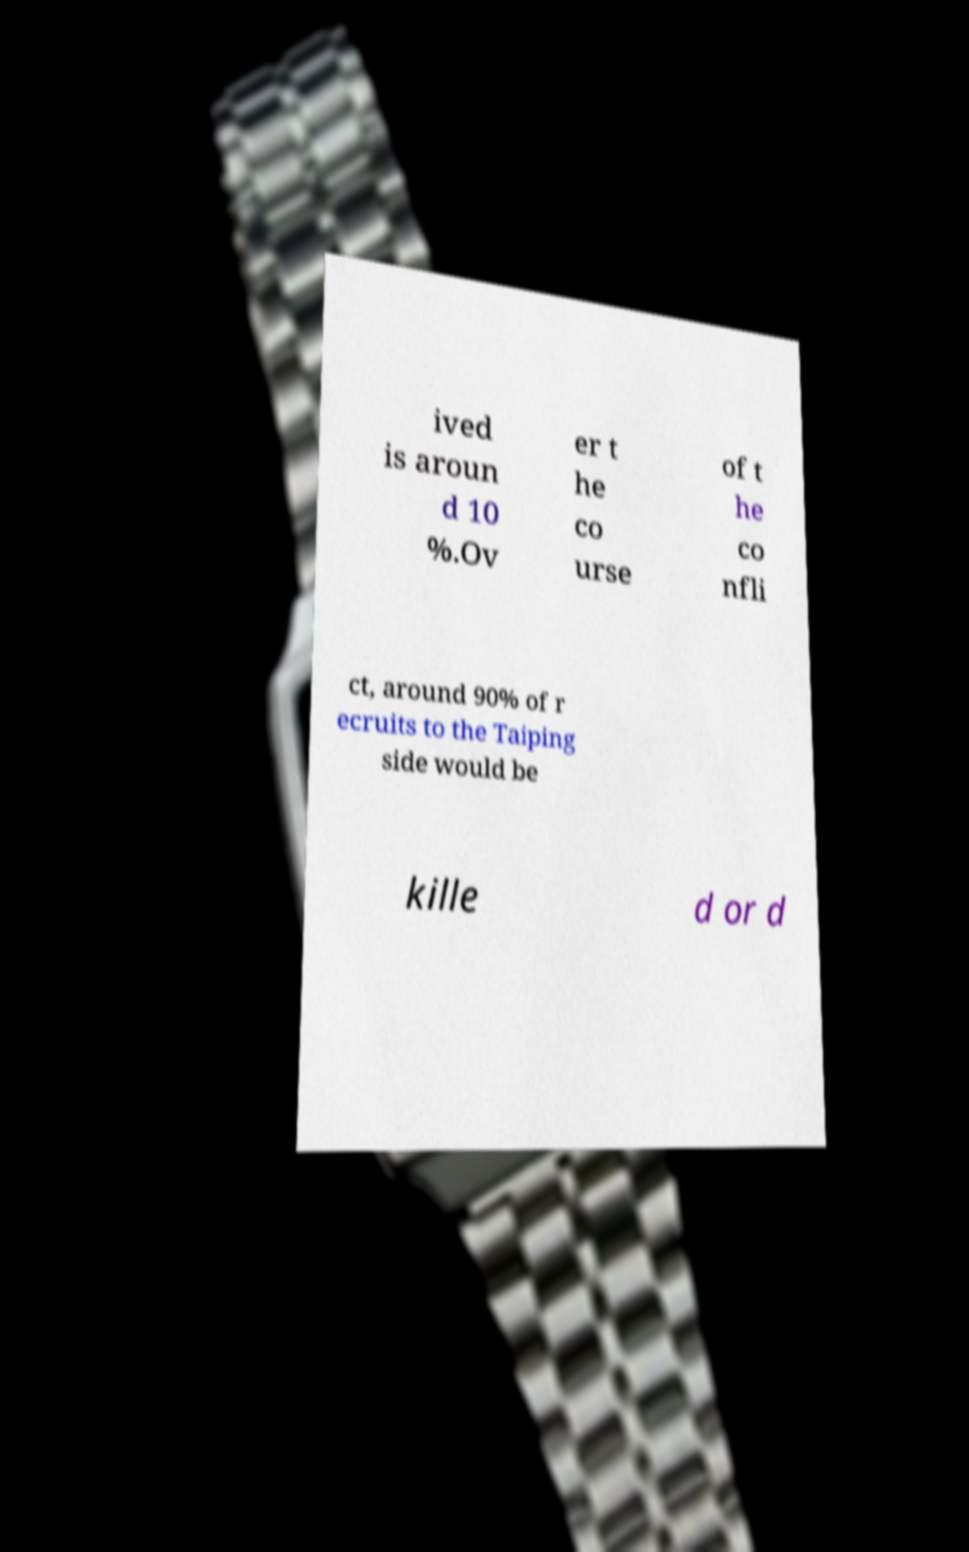Can you read and provide the text displayed in the image?This photo seems to have some interesting text. Can you extract and type it out for me? ived is aroun d 10 %.Ov er t he co urse of t he co nfli ct, around 90% of r ecruits to the Taiping side would be kille d or d 